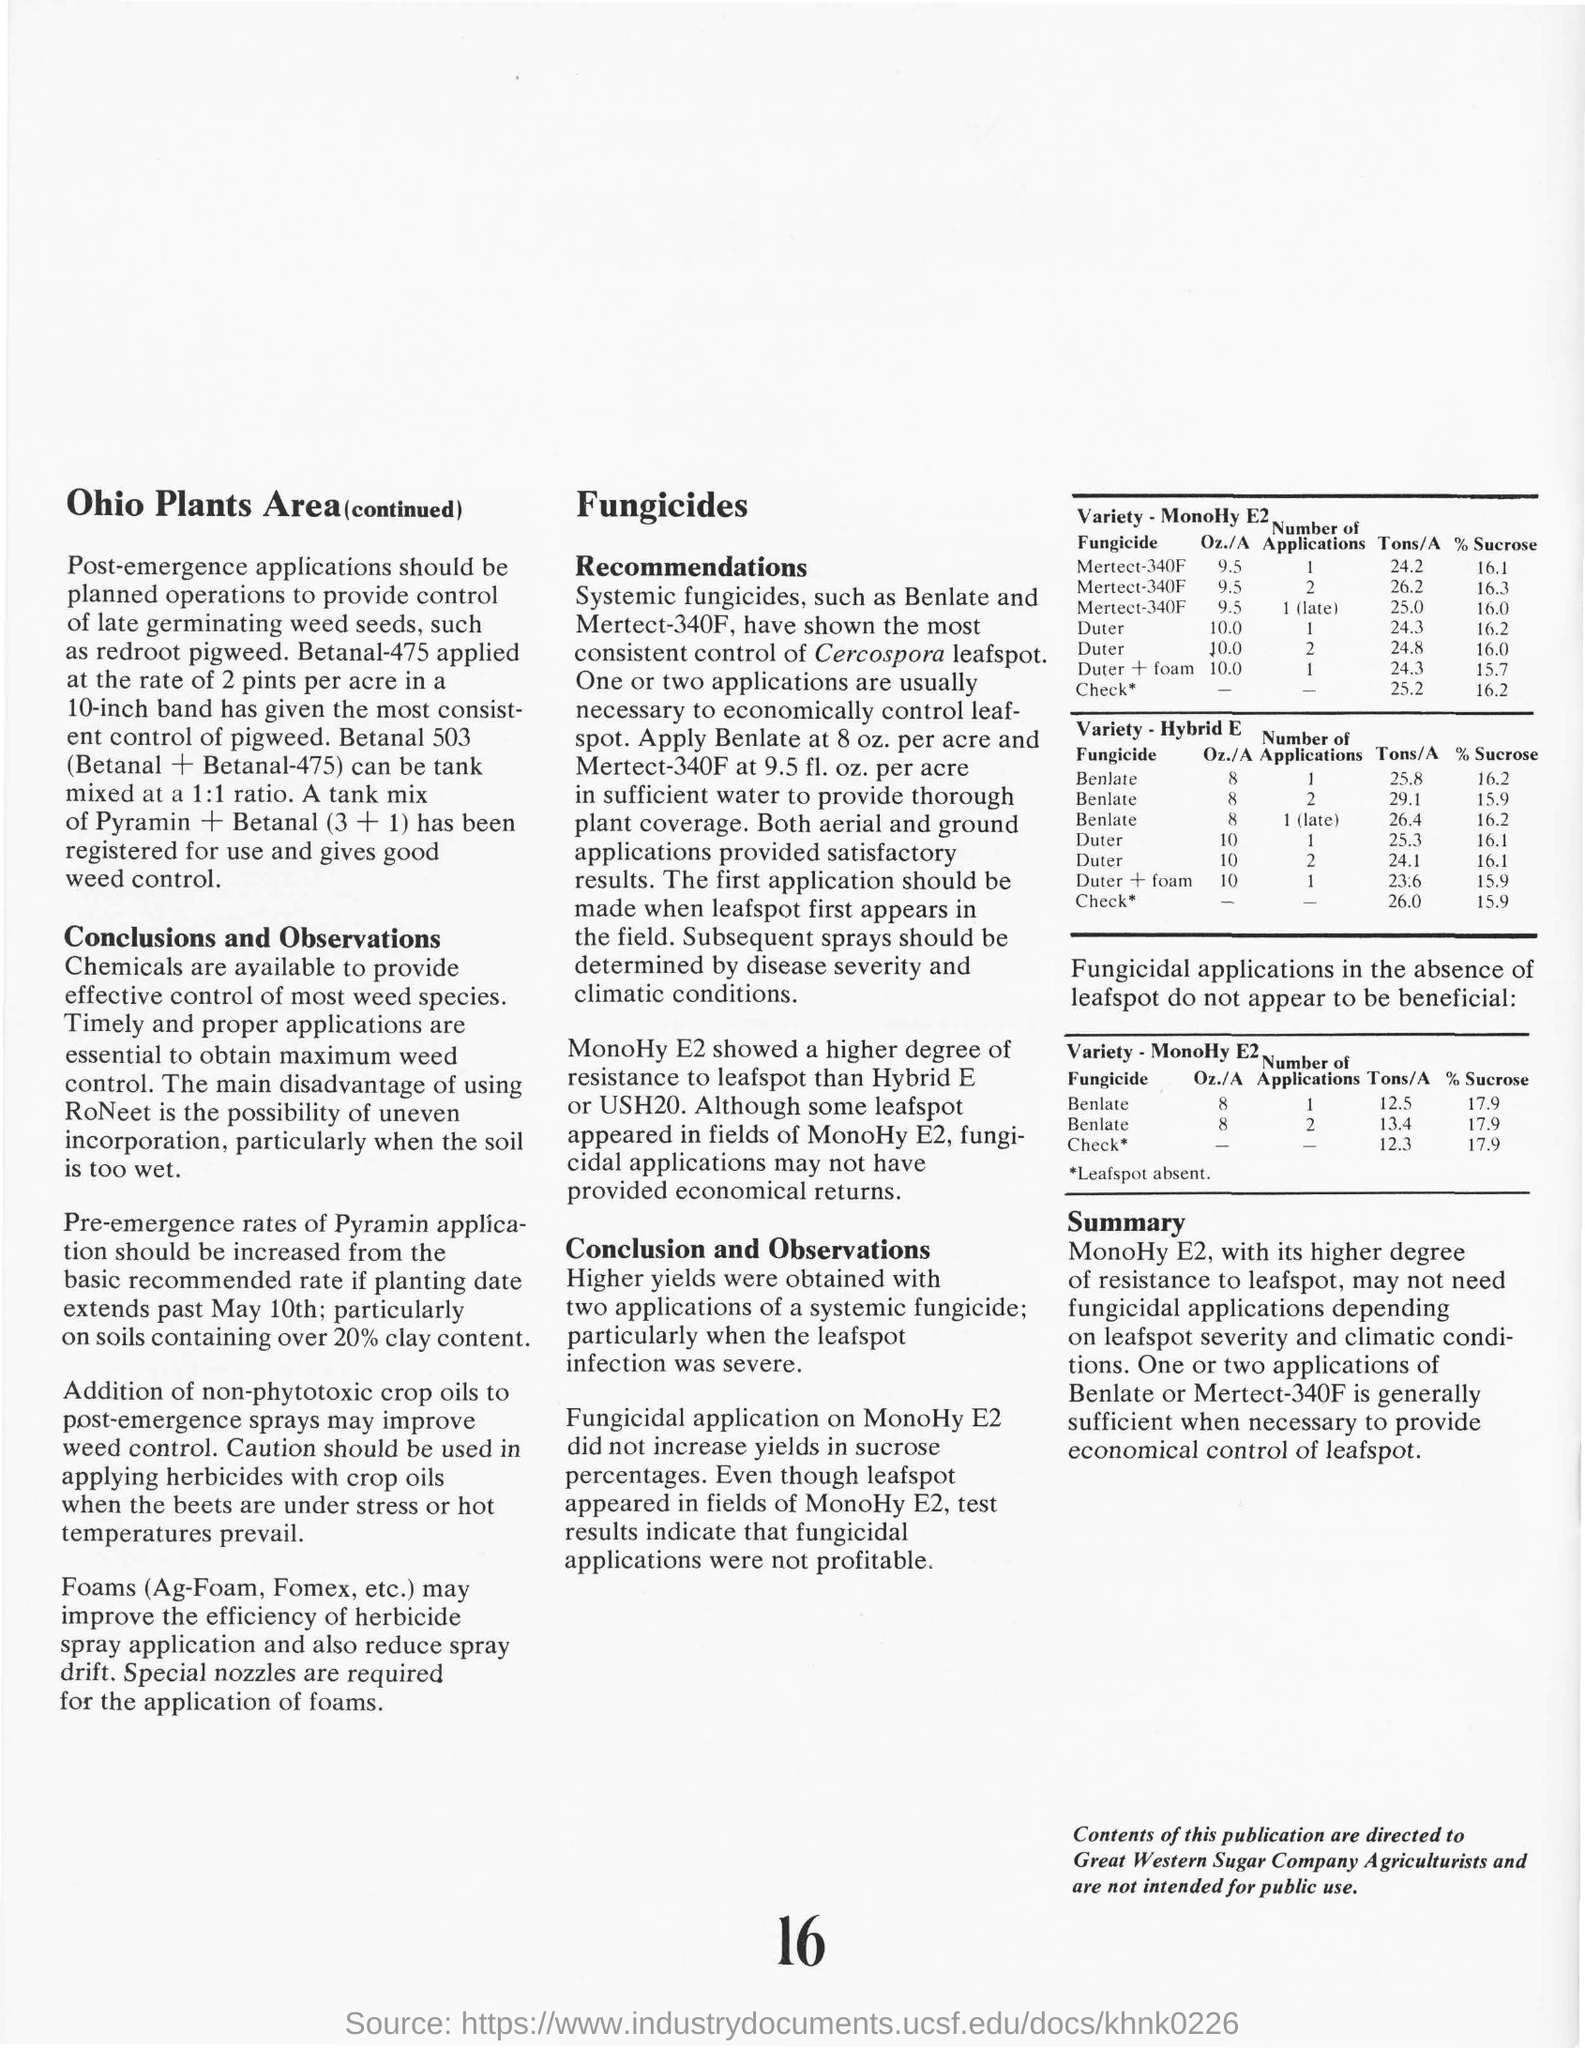Name a late germinating weed seeds?
Provide a short and direct response. Redroot pigweed. What is the ratio of Betanal and Betanal-475 for tank mixing?
Your response must be concise. 1:1 ratio. Which fungicides have shown the most consistent control of Cercospora leafspot?
Your response must be concise. Benlate and Mertect-340F. How much is the Sucrose% when Duter is applied 2 times 10 Oz./A on Variety - MonoHy E2 24.8 Tons/A?
Make the answer very short. 16.0%. 